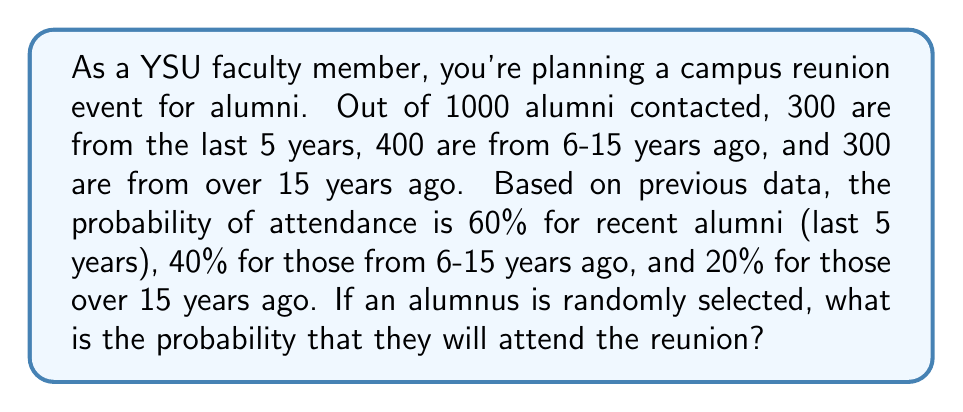Help me with this question. To solve this problem, we'll use the law of total probability. Let's break it down step by step:

1) First, let's define our events:
   A: The event that an alumnus attends the reunion
   R: The event that an alumnus is from the last 5 years
   M: The event that an alumnus is from 6-15 years ago
   O: The event that an alumnus is from over 15 years ago

2) We're given the following probabilities:
   $P(R) = \frac{300}{1000} = 0.3$
   $P(M) = \frac{400}{1000} = 0.4$
   $P(O) = \frac{300}{1000} = 0.3$
   $P(A|R) = 0.6$
   $P(A|M) = 0.4$
   $P(A|O) = 0.2$

3) The law of total probability states:
   $P(A) = P(A|R)P(R) + P(A|M)P(M) + P(A|O)P(O)$

4) Let's substitute our values:
   $P(A) = (0.6)(0.3) + (0.4)(0.4) + (0.2)(0.3)$

5) Now let's calculate:
   $P(A) = 0.18 + 0.16 + 0.06 = 0.40$

Therefore, the probability that a randomly selected alumnus will attend the reunion is 0.40 or 40%.
Answer: The probability that a randomly selected alumnus will attend the reunion is 0.40 or 40%. 